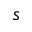Convert formula to latex. <formula><loc_0><loc_0><loc_500><loc_500>s</formula> 